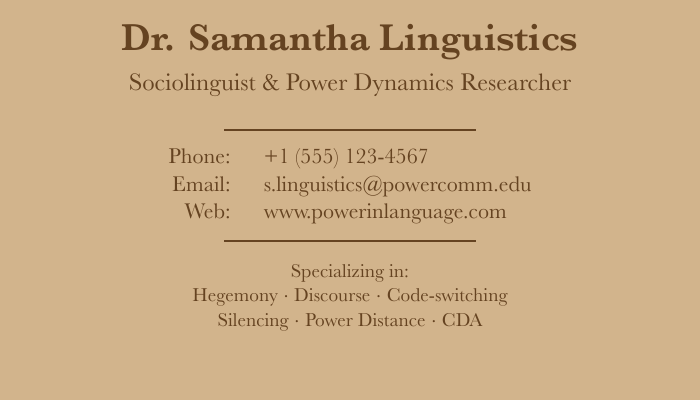What is the name on the business card? The name on the business card is listed at the top of the document as the individual's name.
Answer: Dr. Samantha Linguistics What is the individual's phone number? The phone number is provided in the contact information section of the business card.
Answer: +1 (555) 123-4567 What is the individual's email address? The email address is included in the contact section, providing a way to reach the individual.
Answer: s.linguistics@powercomm.edu What is the primary area of specialization? The area of specialization is mentioned in the list of specialties at the bottom of the card.
Answer: Hegemony How many specialties are listed on the card? The number of specialties can be counted from the list provided in the document.
Answer: Six What does CDA stand for in the context of this document? CDA is one of the specializations mentioned, usually referring to Critical Discourse Analysis in linguistics.
Answer: Critical Discourse Analysis What color is the background of the business card? The background color of the business card is stated in the formatting of the document.
Answer: Light brown What type of document is represented here? The document type can be identified by its layout and content structure, focusing on personal and professional information.
Answer: Business card What professional title is displayed on the card? The professional title is mentioned under the name, indicating the person's role.
Answer: Sociolinguist & Power Dynamics Researcher 